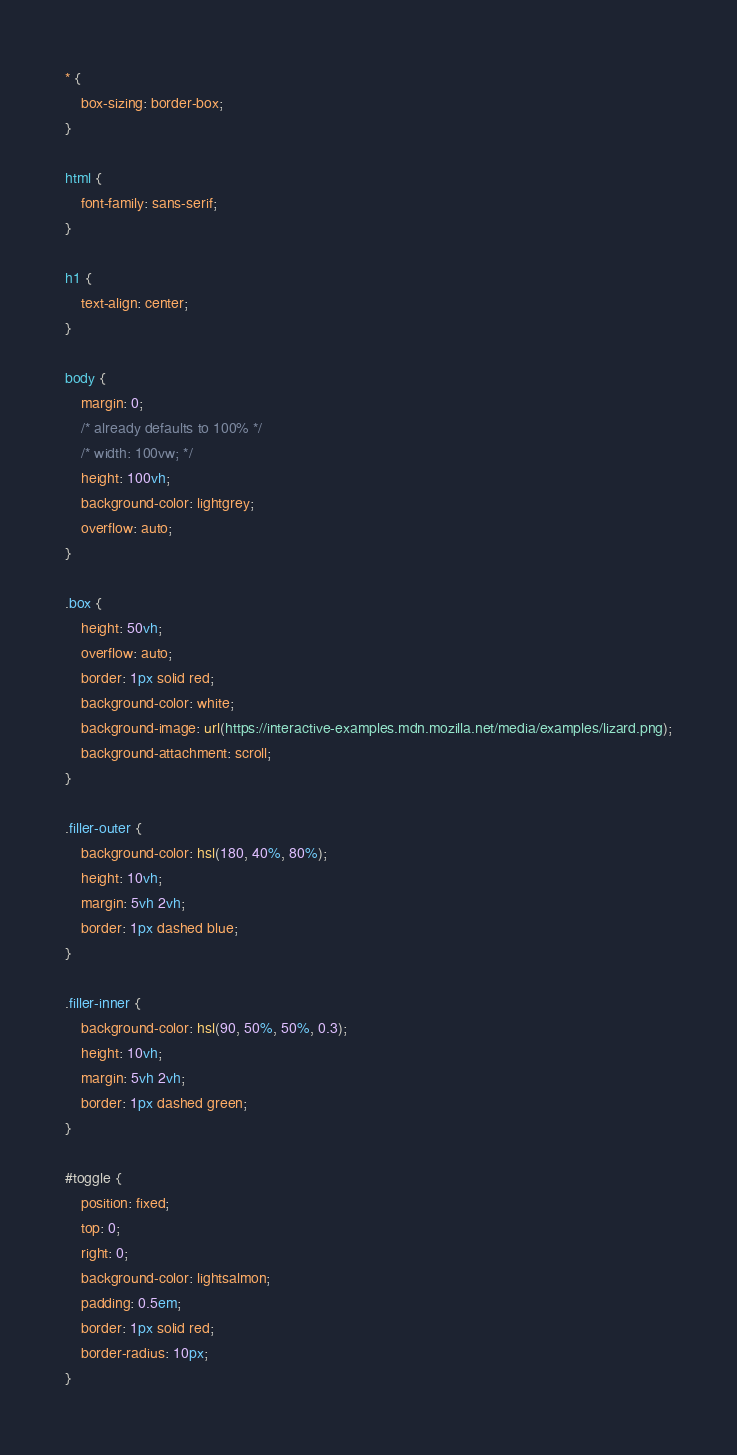<code> <loc_0><loc_0><loc_500><loc_500><_CSS_>* {
    box-sizing: border-box;
}

html {
    font-family: sans-serif;
}

h1 {
    text-align: center;
}

body {
    margin: 0;
    /* already defaults to 100% */
    /* width: 100vw; */
    height: 100vh;
    background-color: lightgrey;
    overflow: auto;
}

.box {
    height: 50vh;
    overflow: auto;
    border: 1px solid red;
    background-color: white;
    background-image: url(https://interactive-examples.mdn.mozilla.net/media/examples/lizard.png);
    background-attachment: scroll;
}

.filler-outer {
    background-color: hsl(180, 40%, 80%);
    height: 10vh;
    margin: 5vh 2vh;
    border: 1px dashed blue;
}

.filler-inner {
    background-color: hsl(90, 50%, 50%, 0.3);
    height: 10vh;
    margin: 5vh 2vh;
    border: 1px dashed green;
}

#toggle {
    position: fixed;
    top: 0;
    right: 0;
    background-color: lightsalmon;
    padding: 0.5em;
    border: 1px solid red;
    border-radius: 10px;
}
</code> 